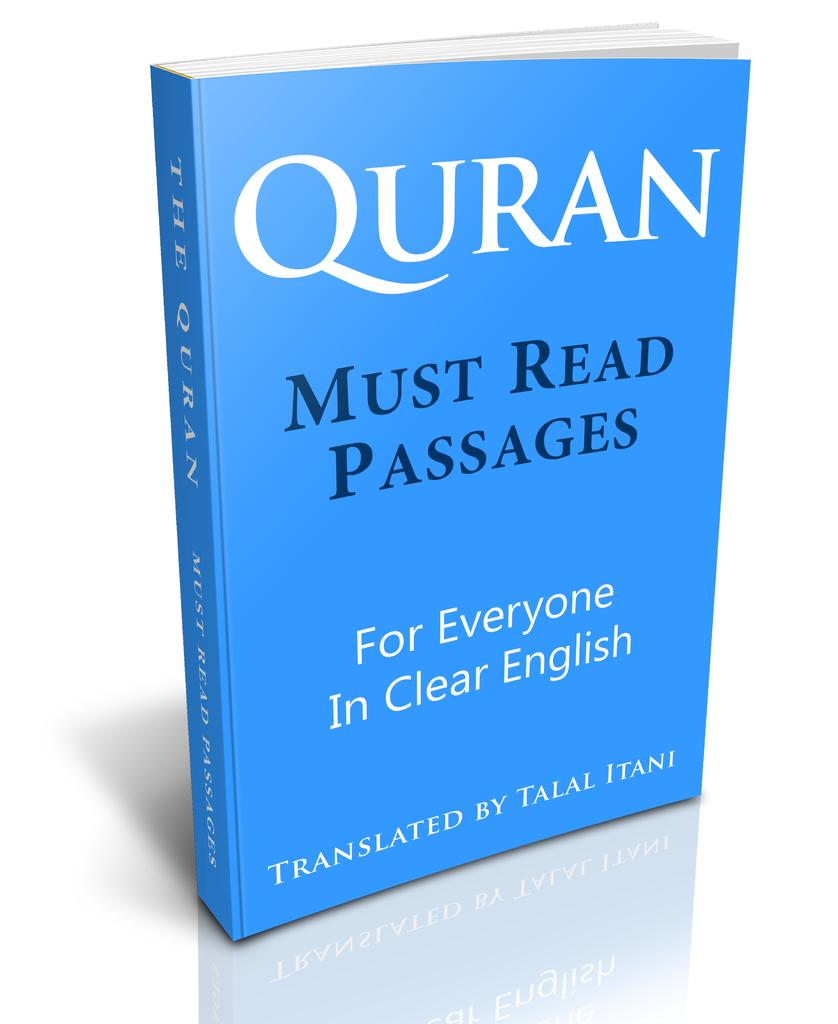What religious text is present in the image? There is a Quran in the picture. What is the color of the Quran? The Quran is blue in color. What is written on the Quran? The Quran has must-read passages for everyone written on it. What language are the must-read passages in? The must-read passages are in English. Who translated the Quran? The Quran is translated by Talal Itani. What type of leaf is depicted in the image? There is no leaf present in the image; it features a Quran. How many nations are represented in the image? The image does not depict any nations; it features a Quran. 